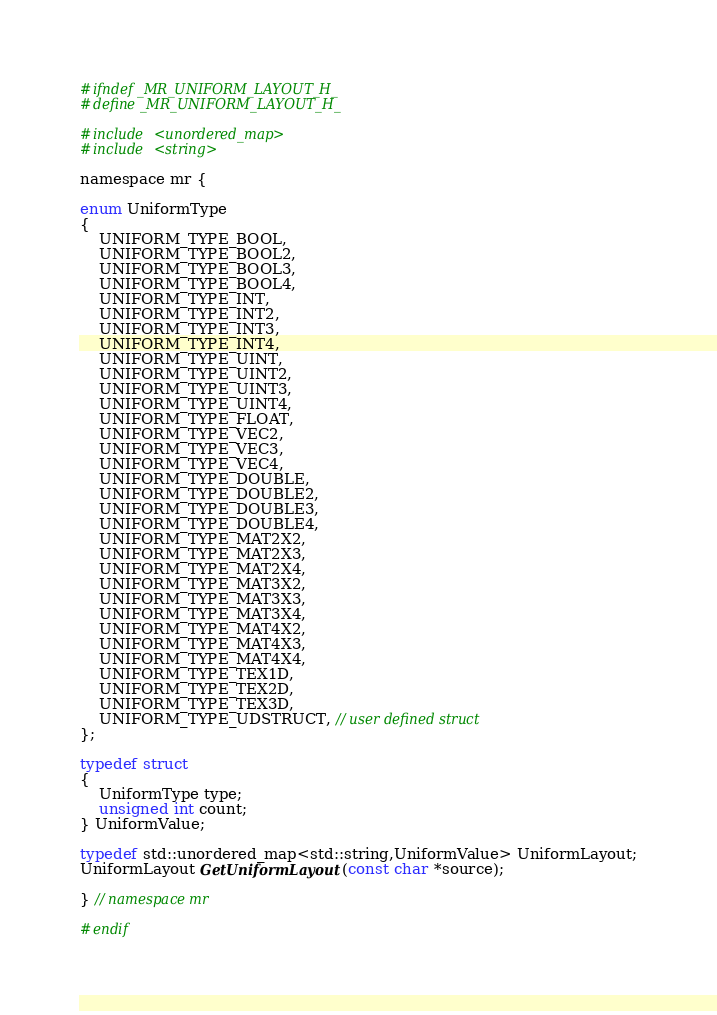<code> <loc_0><loc_0><loc_500><loc_500><_C_>#ifndef _MR_UNIFORM_LAYOUT_H_
#define _MR_UNIFORM_LAYOUT_H_

#include <unordered_map>
#include <string>

namespace mr {

enum UniformType
{
    UNIFORM_TYPE_BOOL,
    UNIFORM_TYPE_BOOL2,
    UNIFORM_TYPE_BOOL3,
    UNIFORM_TYPE_BOOL4,
    UNIFORM_TYPE_INT,
    UNIFORM_TYPE_INT2,
    UNIFORM_TYPE_INT3,
    UNIFORM_TYPE_INT4,
    UNIFORM_TYPE_UINT,
    UNIFORM_TYPE_UINT2,
    UNIFORM_TYPE_UINT3,
    UNIFORM_TYPE_UINT4,
    UNIFORM_TYPE_FLOAT,
    UNIFORM_TYPE_VEC2,
    UNIFORM_TYPE_VEC3,
    UNIFORM_TYPE_VEC4,
    UNIFORM_TYPE_DOUBLE,
    UNIFORM_TYPE_DOUBLE2,
    UNIFORM_TYPE_DOUBLE3,
    UNIFORM_TYPE_DOUBLE4,
    UNIFORM_TYPE_MAT2X2,
    UNIFORM_TYPE_MAT2X3,
    UNIFORM_TYPE_MAT2X4,
    UNIFORM_TYPE_MAT3X2,
    UNIFORM_TYPE_MAT3X3,
    UNIFORM_TYPE_MAT3X4,
    UNIFORM_TYPE_MAT4X2,
    UNIFORM_TYPE_MAT4X3,
    UNIFORM_TYPE_MAT4X4,
    UNIFORM_TYPE_TEX1D,
    UNIFORM_TYPE_TEX2D,
    UNIFORM_TYPE_TEX3D,
    UNIFORM_TYPE_UDSTRUCT, // user defined struct
};

typedef struct
{
    UniformType type;
    unsigned int count;
} UniformValue;

typedef std::unordered_map<std::string,UniformValue> UniformLayout;
UniformLayout GetUniformLayout(const char *source);

} // namespace mr

#endif
</code> 